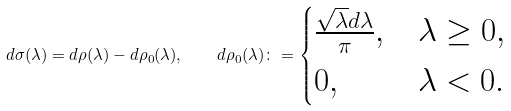Convert formula to latex. <formula><loc_0><loc_0><loc_500><loc_500>d \sigma ( \lambda ) = d \rho ( \lambda ) - d \rho _ { 0 } ( \lambda ) , \quad d \rho _ { 0 } ( \lambda ) \colon = \begin{cases} \frac { \sqrt { \lambda } d \lambda } { \pi } , & \lambda \geq 0 , \\ 0 , & \lambda < 0 . \end{cases}</formula> 